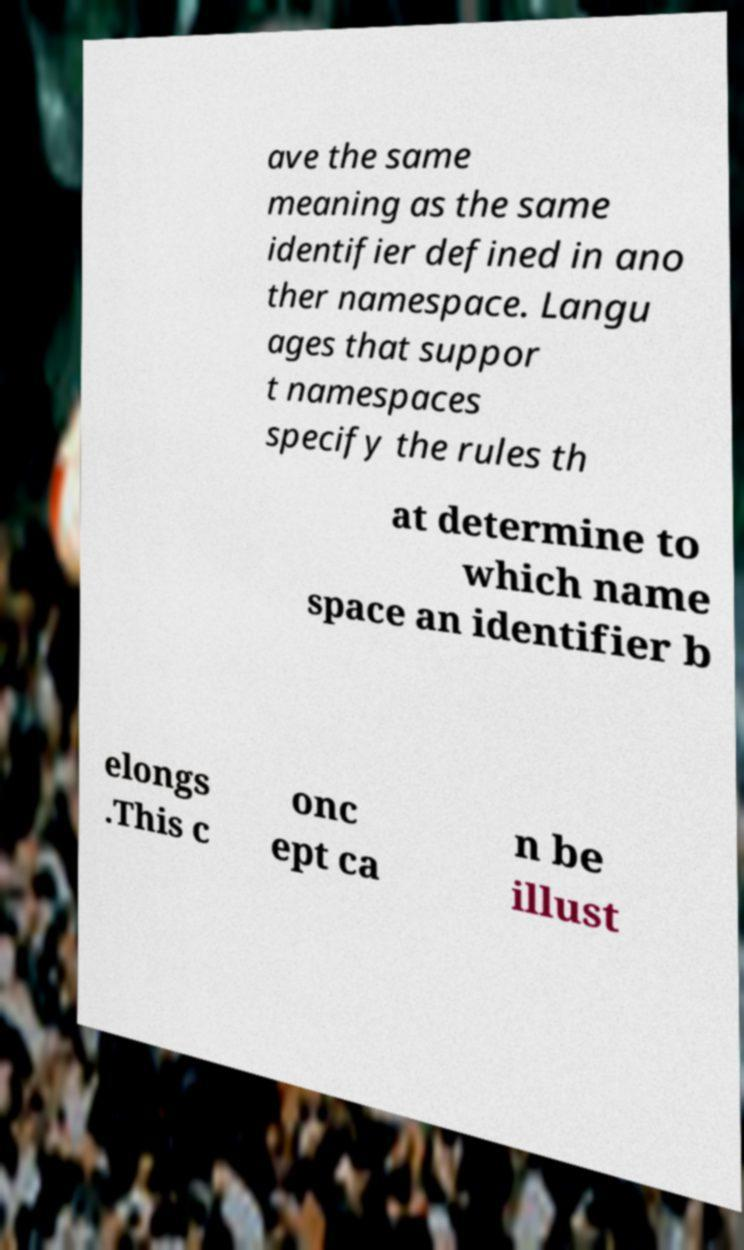I need the written content from this picture converted into text. Can you do that? ave the same meaning as the same identifier defined in ano ther namespace. Langu ages that suppor t namespaces specify the rules th at determine to which name space an identifier b elongs .This c onc ept ca n be illust 